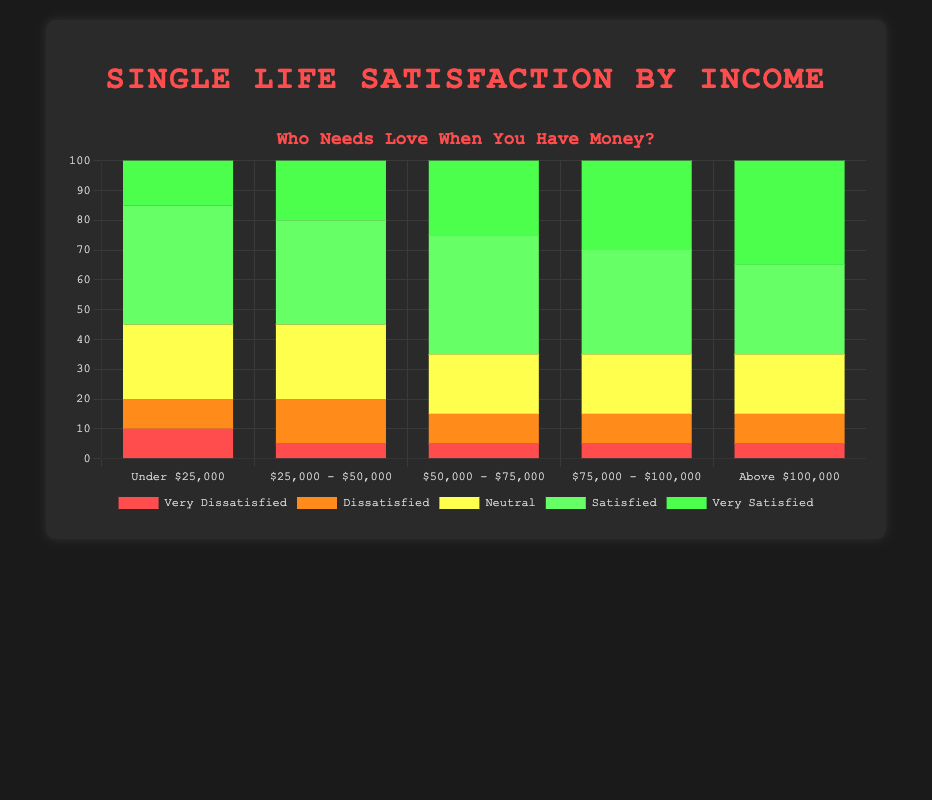Which income bracket has the highest percentage of very satisfied individuals? By looking at the height of the green segments that represent 'very satisfied' individuals, we can see that the 'Above $100,000' bracket has the highest percentage at 35%.
Answer: Above $100,000 What is the sum of the percentages of dissatisfied and very dissatisfied individuals for the $25,000 - $50,000 income range? The percentage of dissatisfied individuals in the $25,000 - $50,000 income range is 15%, and the percentage of very dissatisfied individuals is 5%. Summing these gives 15% + 5% = 20%.
Answer: 20% Is the percentage of neutral individuals the same in the $50,000 - $75,000 and the $75,000 - $100,000 income ranges? By observing the yellow segments labeled 'neutral', we can see both the $50,000 - $75,000 and $75,000 - $100,000 brackets have 20% neutral individuals.
Answer: Yes Which income bracket has the smallest percentage of very dissatisfied individuals? By comparing the height of the red segments for 'very dissatisfied' individuals, the answer is that all income brackets except 'Under $25,000' have the smallest percentage at 5%.
Answer: All except Under $25,000 How does the satisfaction level compare between the 'Under $25,000' and 'Above $100,000' income brackets? In the 'Under $25,000' bracket, 15% are very satisfied and 40% are satisfied, whereas in the 'Above $100,000' bracket, 35% are very satisfied and 30% are satisfied. This shows an increase in the very satisfied percentage with higher income and a decrease in the satisfied percentage.
Answer: Higher income, more very satisfied, fewer satisfied What is the total percentage of individuals who are either very satisfied or satisfied in the $75,000 - $100,000 income range? In the $75,000 - $100,000 bracket, 30% are very satisfied and 35% are satisfied. The total is 30% + 35% = 65%.
Answer: 65% Is there a consistent trend in the percentage of very satisfied individuals as income increases? By examining the green segments from left to right (increasing income), the percentage of very satisfied individuals increases consistently: 15%, 20%, 25%, 30%, and 35%.
Answer: Yes 